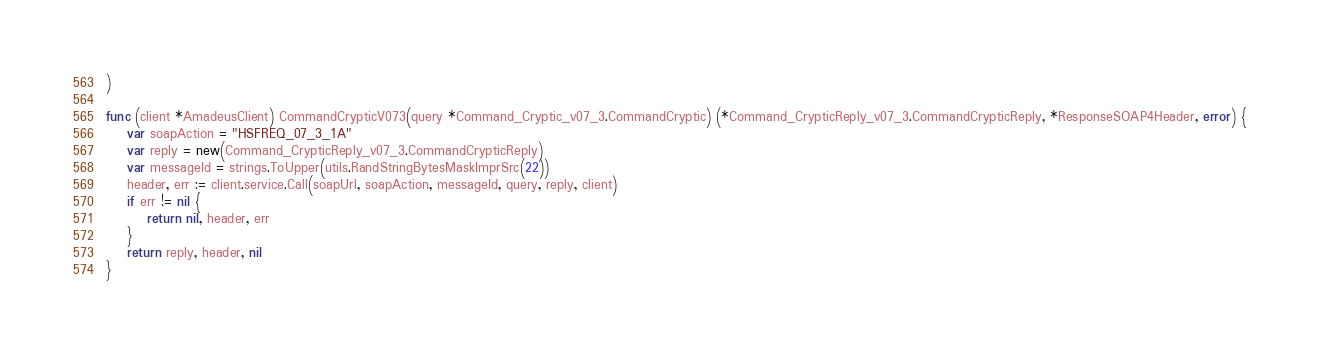Convert code to text. <code><loc_0><loc_0><loc_500><loc_500><_Go_>)

func (client *AmadeusClient) CommandCrypticV073(query *Command_Cryptic_v07_3.CommandCryptic) (*Command_CrypticReply_v07_3.CommandCrypticReply, *ResponseSOAP4Header, error) {
	var soapAction = "HSFREQ_07_3_1A"
	var reply = new(Command_CrypticReply_v07_3.CommandCrypticReply)
	var messageId = strings.ToUpper(utils.RandStringBytesMaskImprSrc(22))
	header, err := client.service.Call(soapUrl, soapAction, messageId, query, reply, client)
	if err != nil {
		return nil, header, err
	}
	return reply, header, nil
}
</code> 